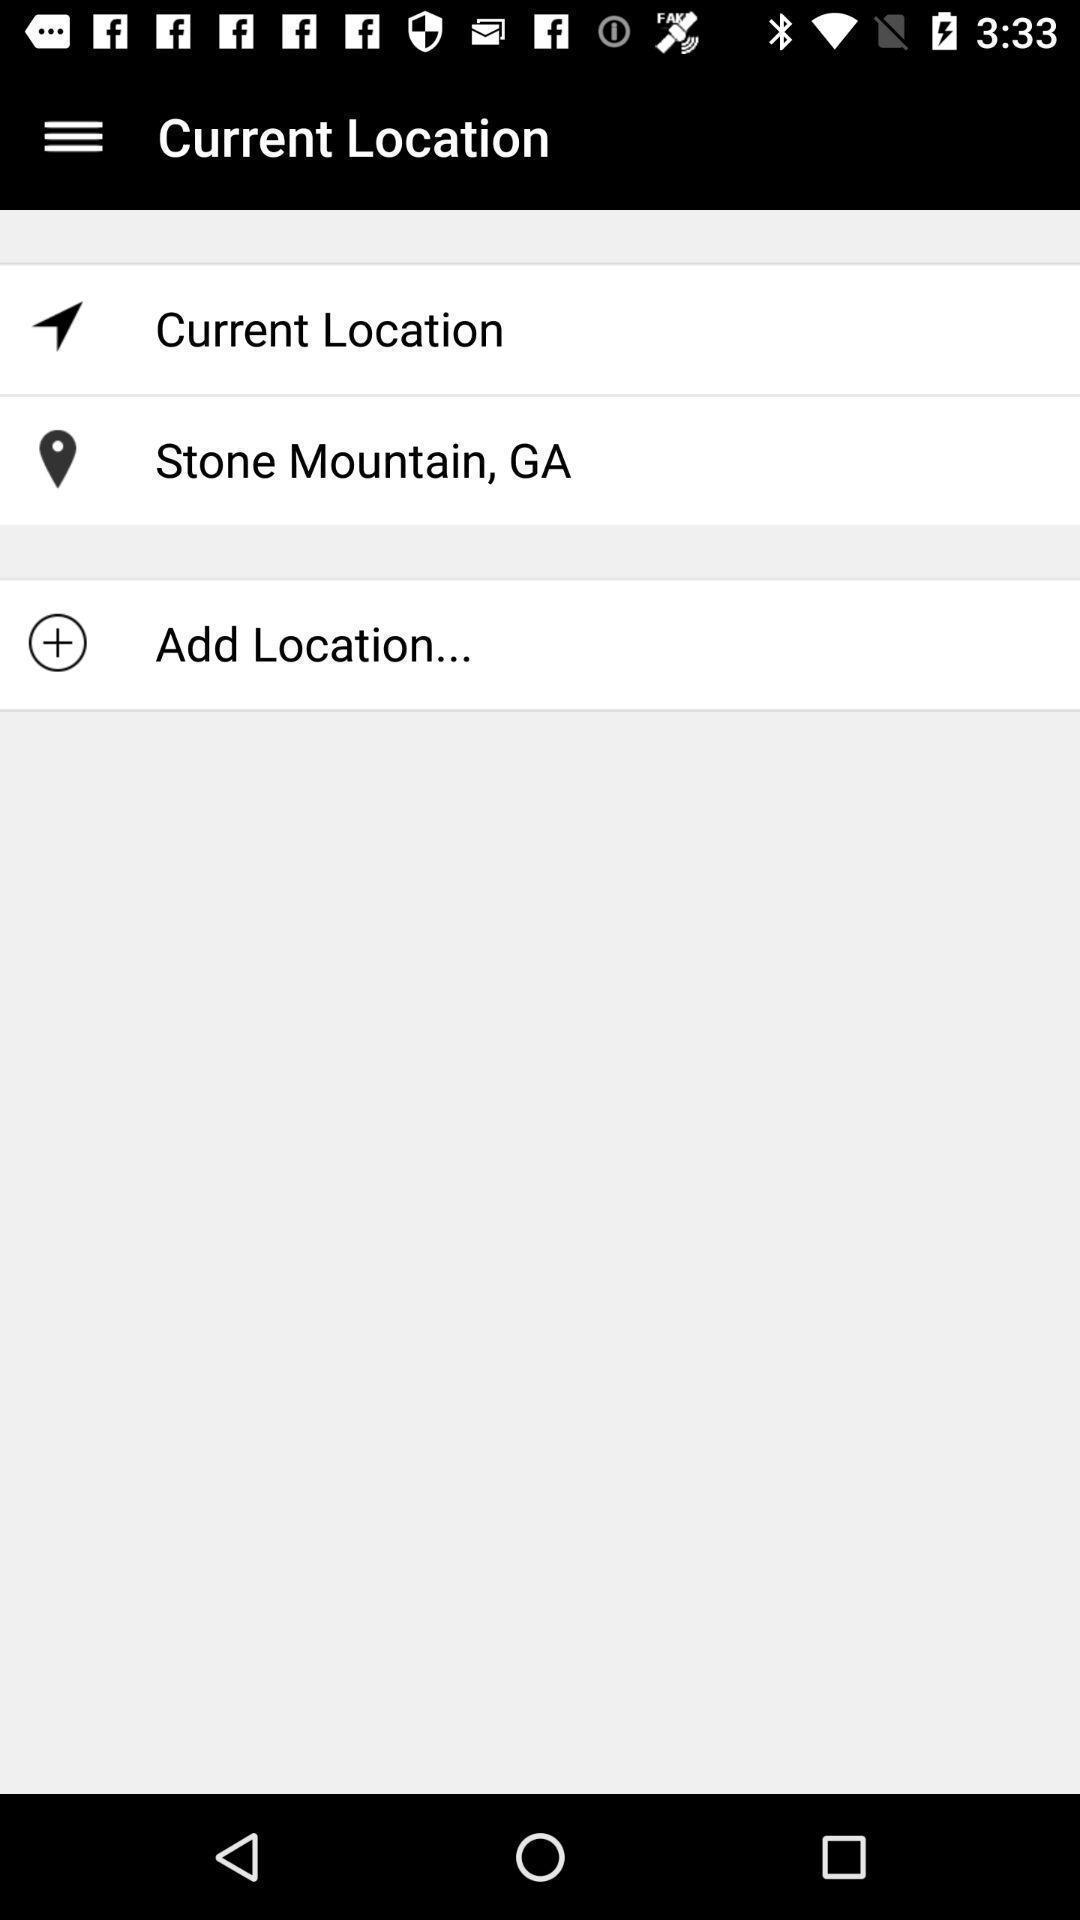Explain the elements present in this screenshot. Screen shows current location details. 